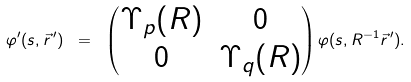Convert formula to latex. <formula><loc_0><loc_0><loc_500><loc_500>\varphi ^ { \prime } ( s , \vec { r } \, ^ { \prime } ) \ = \ \begin{pmatrix} \Upsilon _ { p } ( R ) & 0 \\ 0 & \Upsilon _ { q } ( R ) \end{pmatrix} \varphi ( s , R ^ { - 1 } \vec { r } \, ^ { \prime } ) .</formula> 